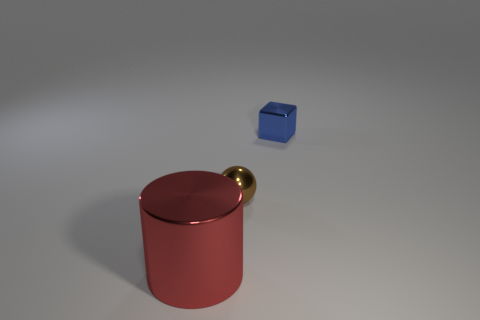Is there anything else that has the same shape as the tiny blue metallic object?
Make the answer very short. No. How many big red metallic things are behind the small shiny object to the right of the small metallic object to the left of the blue object?
Offer a very short reply. 0. What number of blue things are large cylinders or small metal cylinders?
Ensure brevity in your answer.  0. Is the size of the red thing the same as the object right of the brown shiny ball?
Your response must be concise. No. What number of other things are there of the same size as the shiny ball?
Give a very brief answer. 1. There is a object behind the tiny object that is left of the thing that is on the right side of the metallic ball; what is its shape?
Offer a terse response. Cube. What is the shape of the object that is both left of the small blue metallic thing and to the right of the big metal thing?
Your answer should be very brief. Sphere. How many things are either large brown metal balls or things that are to the left of the tiny block?
Provide a short and direct response. 2. Do the small brown sphere and the large red cylinder have the same material?
Make the answer very short. Yes. What number of other objects are the same shape as the tiny blue metal thing?
Your answer should be compact. 0. 